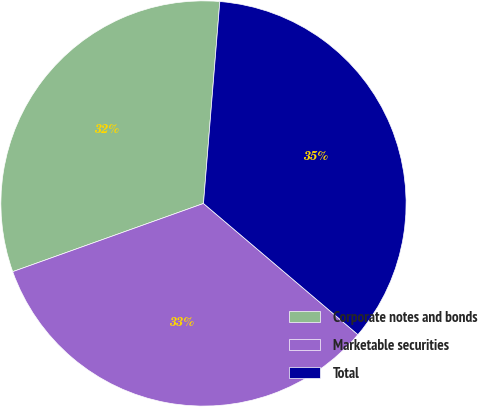<chart> <loc_0><loc_0><loc_500><loc_500><pie_chart><fcel>Corporate notes and bonds<fcel>Marketable securities<fcel>Total<nl><fcel>31.75%<fcel>33.33%<fcel>34.92%<nl></chart> 